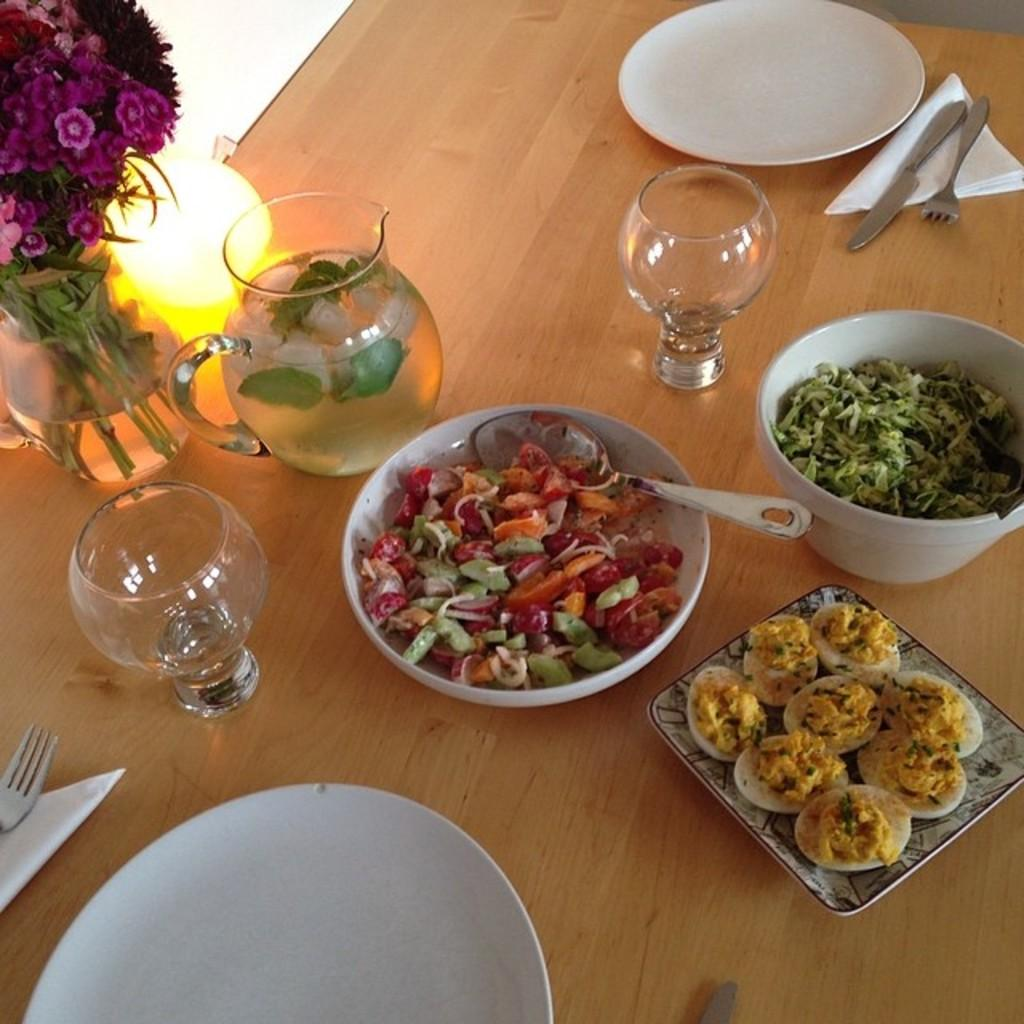What piece of furniture is present in the image? There is a table in the image. What is placed on the table? There is a flask, glasses, a plate with food, a spoon, and a flower vase on the table. What type of container is used for holding liquid on the table? There is a flask on the table for holding liquid. What might be used for eating the food on the table? The spoon on the table can be used for eating the food. What type of vein is visible on the table in the image? There are no veins visible on the table in the image. What type of vest is being worn by the person in the image? There is no person present in the image, so it is not possible to determine what type of vest they might be wearing. 